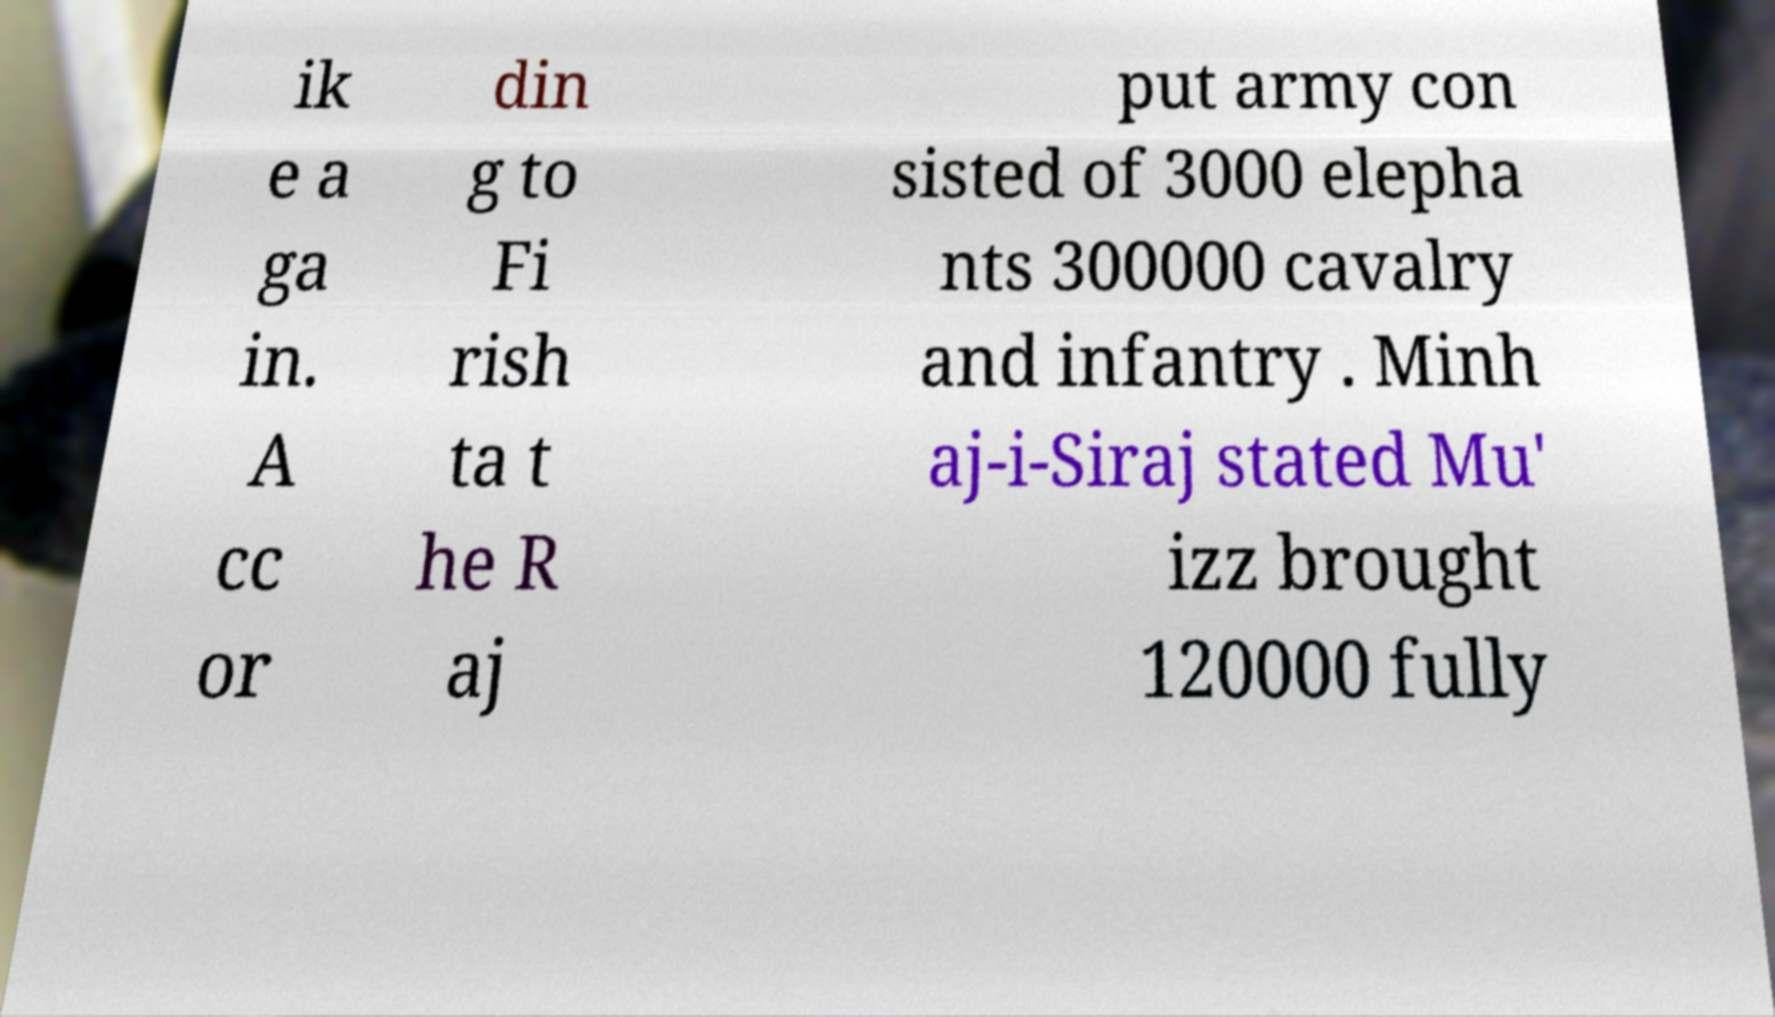Can you read and provide the text displayed in the image?This photo seems to have some interesting text. Can you extract and type it out for me? ik e a ga in. A cc or din g to Fi rish ta t he R aj put army con sisted of 3000 elepha nts 300000 cavalry and infantry . Minh aj-i-Siraj stated Mu' izz brought 120000 fully 